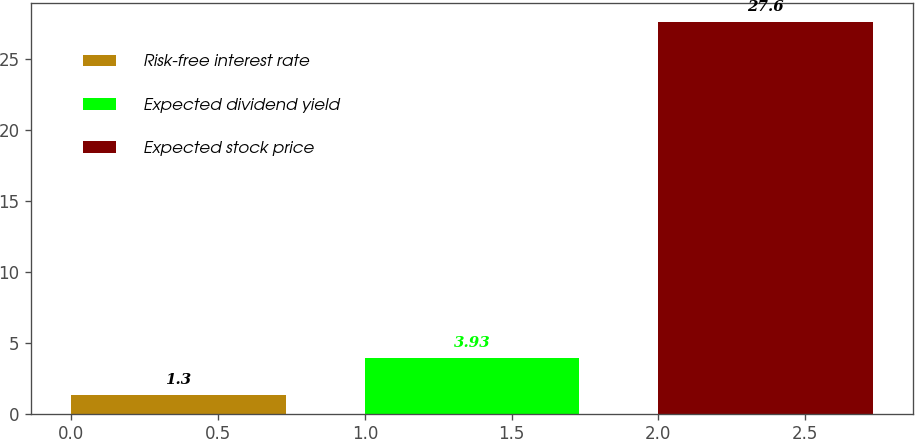<chart> <loc_0><loc_0><loc_500><loc_500><bar_chart><fcel>Risk-free interest rate<fcel>Expected dividend yield<fcel>Expected stock price<nl><fcel>1.3<fcel>3.93<fcel>27.6<nl></chart> 